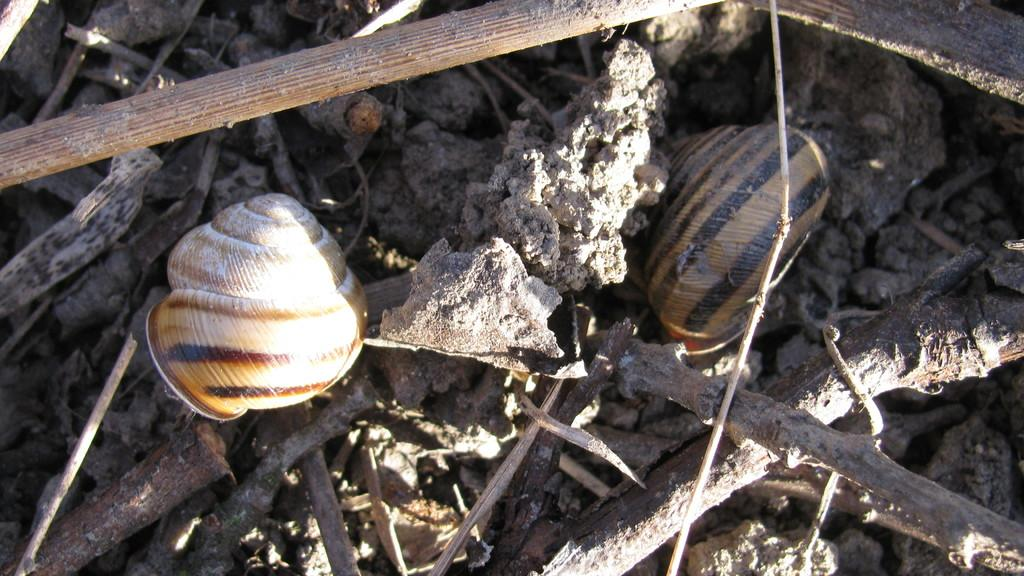What type of objects can be seen in the image? There are two snail shells and wooden sticks in the image. Can you describe the location of these objects? The objects, including the snail shells and wooden sticks, are on the ground in the image. What type of magic can be seen being performed with the snail shells in the image? There is no magic being performed in the image; it simply shows snail shells and wooden sticks on the ground. What type of berry can be seen growing near the snail shells in the image? There is no berry plant or berries visible in the image. 